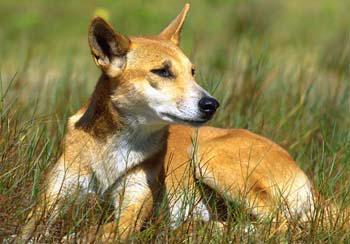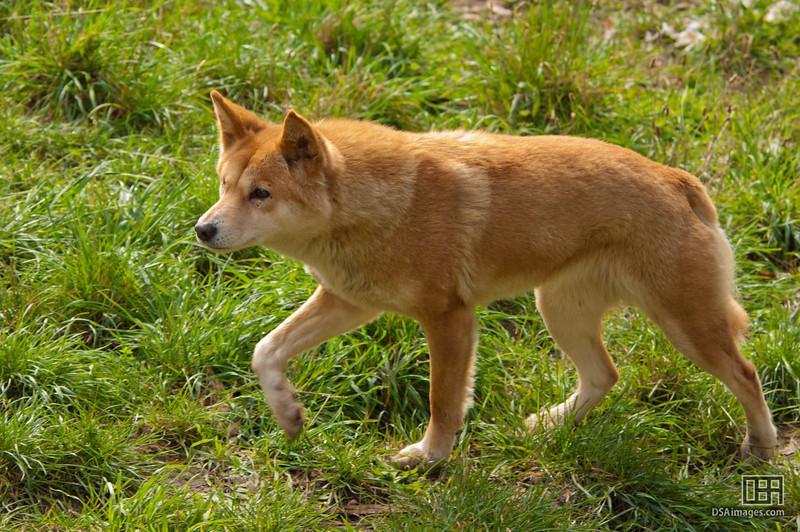The first image is the image on the left, the second image is the image on the right. Examine the images to the left and right. Is the description "All golden colored dogs are standing up in the grass (not laying down.)" accurate? Answer yes or no. No. The first image is the image on the left, the second image is the image on the right. For the images shown, is this caption "One image contains a reclining dingo and the other contains a dingo that is walking with body in profile." true? Answer yes or no. Yes. 